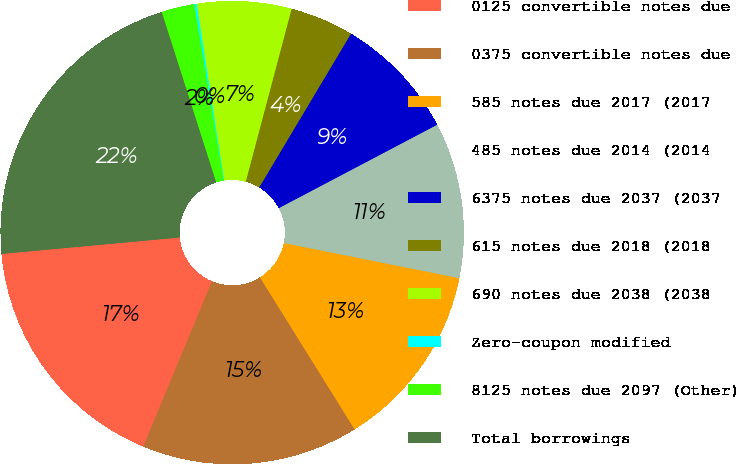Convert chart. <chart><loc_0><loc_0><loc_500><loc_500><pie_chart><fcel>0125 convertible notes due<fcel>0375 convertible notes due<fcel>585 notes due 2017 (2017<fcel>485 notes due 2014 (2014<fcel>6375 notes due 2037 (2037<fcel>615 notes due 2018 (2018<fcel>690 notes due 2038 (2038<fcel>Zero-coupon modified<fcel>8125 notes due 2097 (Other)<fcel>Total borrowings<nl><fcel>17.27%<fcel>15.13%<fcel>12.99%<fcel>10.86%<fcel>8.72%<fcel>4.44%<fcel>6.58%<fcel>0.17%<fcel>2.3%<fcel>21.54%<nl></chart> 